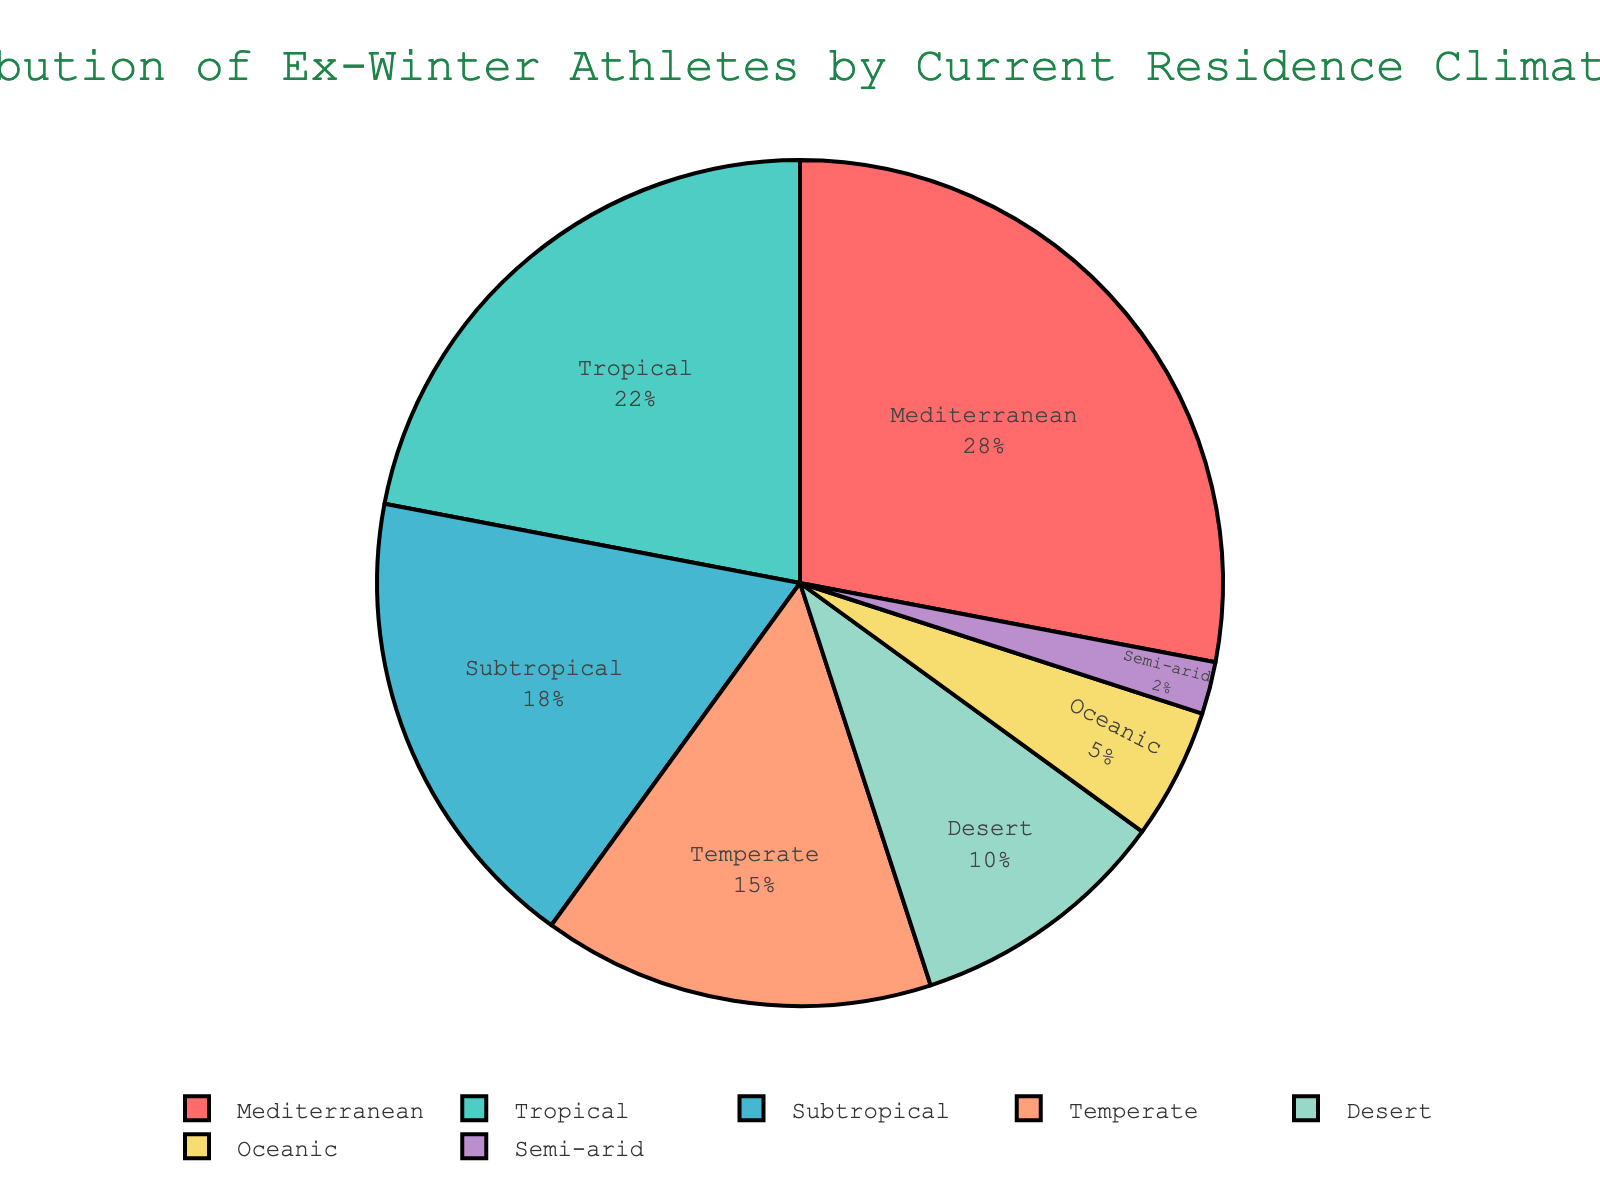Which climate type has the highest percentage of ex-winter athletes? Look at the pie chart and identify the largest segment, which corresponds to the Mediterranean climate type with 28%.
Answer: Mediterranean Which two climate types make up the smallest combined percentage? Identify the segments with the smallest percentages, which are Semi-arid (2%) and Oceanic (5%). Adding them together results in a combined 7%.
Answer: Semi-arid and Oceanic How does the percentage of ex-winter athletes in tropical climates compare to those in Mediterranean climates? Compare the Tropical segment (22%) to the Mediterranean segment (28%). The Mediterranean segment is larger by 6%.
Answer: Mediterranean is 6% higher What is the total percentage of ex-winter athletes living in climates that are not considered snowy (Mediterranean, Tropical, Subtropical, Desert)? Sum the percentages of Mediterranean (28%), Tropical (22%), Subtropical (18%), and Desert (10%) climates. The total is 28 + 22 + 18 + 10 = 78%.
Answer: 78% Among the temperate and tropical climates, which one has a higher percentage and by how much? Compare the Temperate segment (15%) to the Tropical segment (22%). The Tropical segment is higher by 22 - 15 = 7%.
Answer: Tropical by 7% What is the combined percentage of ex-winter athletes living in Oceanic and Subtropical climates? Add the percentages of Oceanic (5%) and Subtropical (18%) climates. The total is 5 + 18 = 23%.
Answer: 23% Which climate type is represented by the smallest segment in the pie chart? Identify the smallest segment, which corresponds to the Semi-arid climate type with 2%.
Answer: Semi-arid Is the percentage of ex-winter athletes in Oceanic climates greater than the percentage in Desert climates? Compare the Oceanic segment (5%) to the Desert segment (10%). The Oceanic segment is smaller.
Answer: No What is the average percentage of ex-winter athletes across all the listed climate types? Sum all the percentages (28 + 22 + 18 + 15 + 10 + 5 + 2 = 100%) and divide by the number of climate types (7). The average is 100 / 7 ≈ 14.29%.
Answer: 14.29 